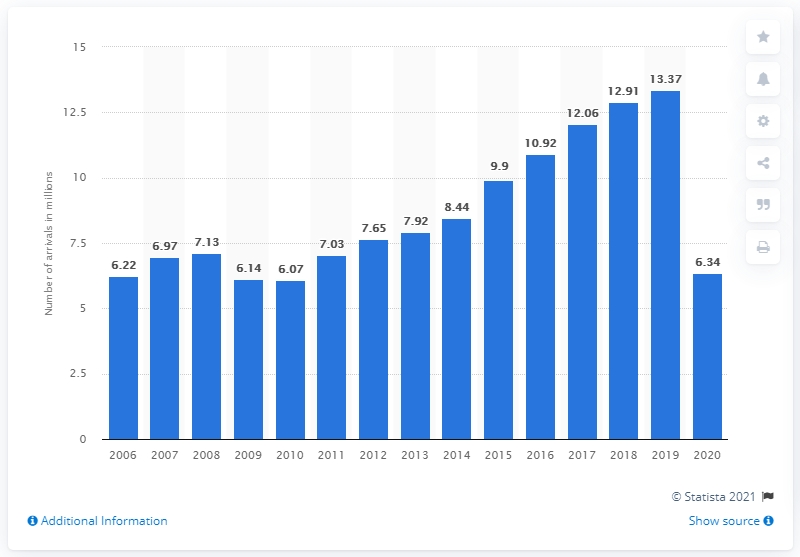Draw attention to some important aspects in this diagram. By 2019, there were 12,910 recorded tourist arrivals at accommodation establishments. In 2020, the total number of tourist arrivals in Romania was 6,340. 